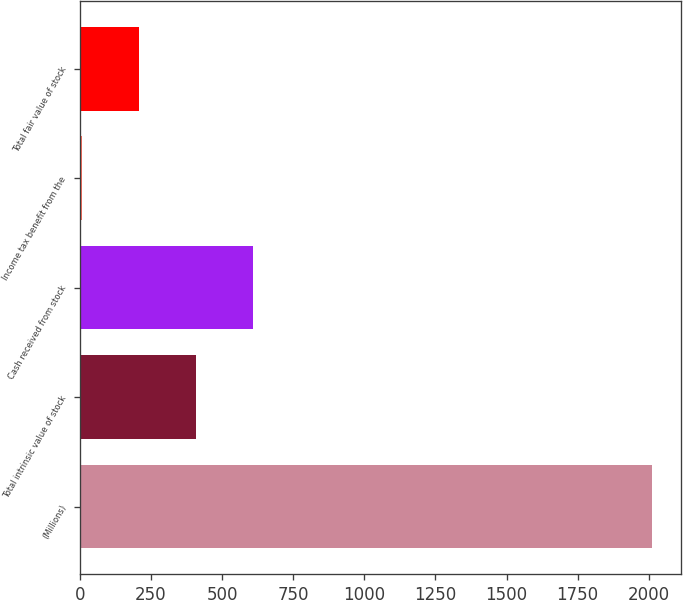Convert chart. <chart><loc_0><loc_0><loc_500><loc_500><bar_chart><fcel>(Millions)<fcel>Total intrinsic value of stock<fcel>Cash received from stock<fcel>Income tax benefit from the<fcel>Total fair value of stock<nl><fcel>2011<fcel>409.4<fcel>609.6<fcel>9<fcel>209.2<nl></chart> 